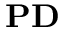Convert formula to latex. <formula><loc_0><loc_0><loc_500><loc_500>P D</formula> 